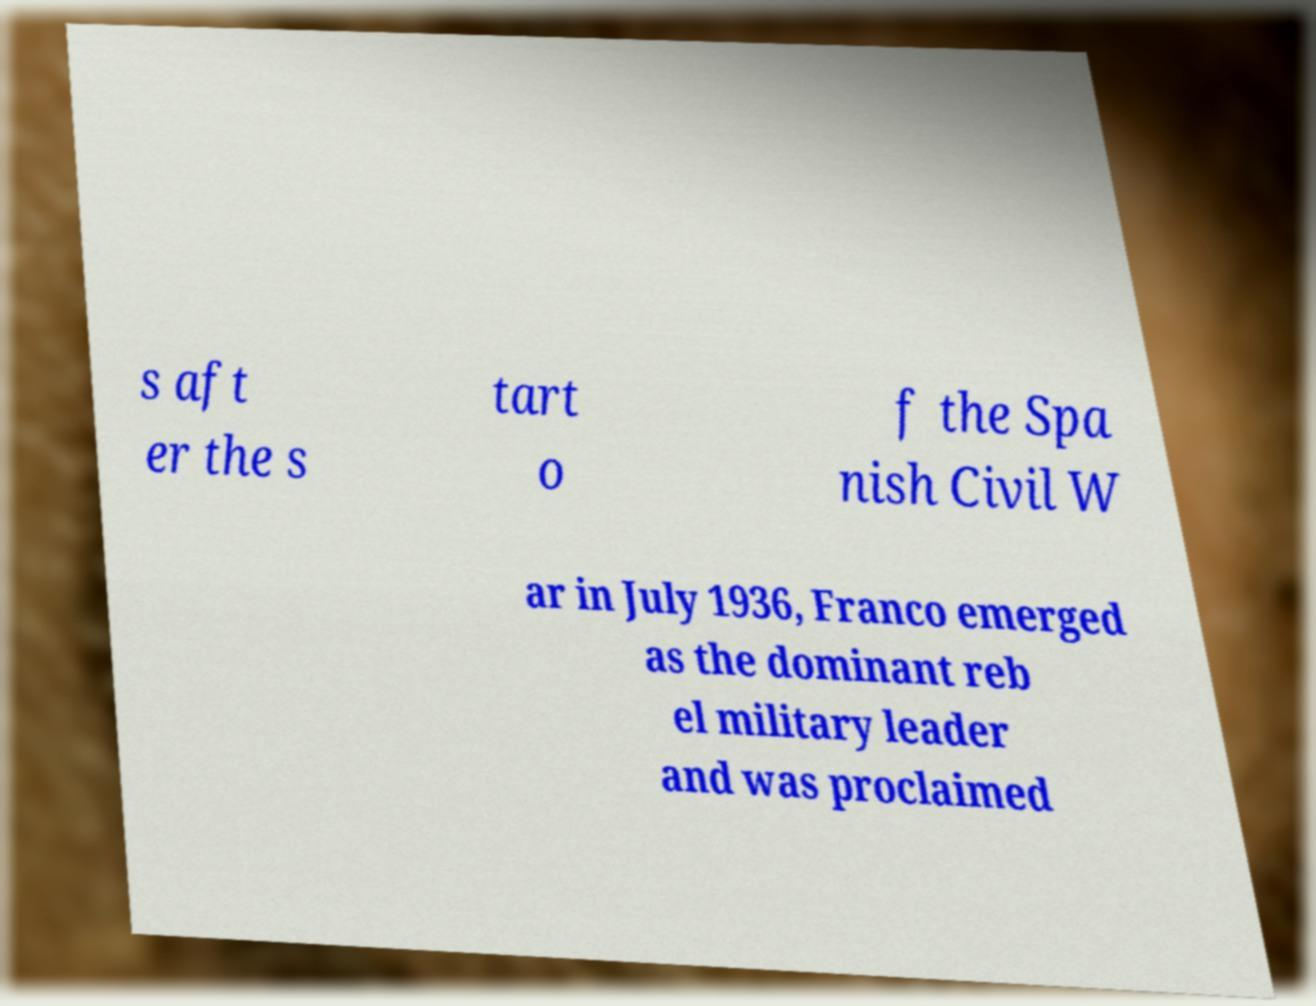There's text embedded in this image that I need extracted. Can you transcribe it verbatim? s aft er the s tart o f the Spa nish Civil W ar in July 1936, Franco emerged as the dominant reb el military leader and was proclaimed 